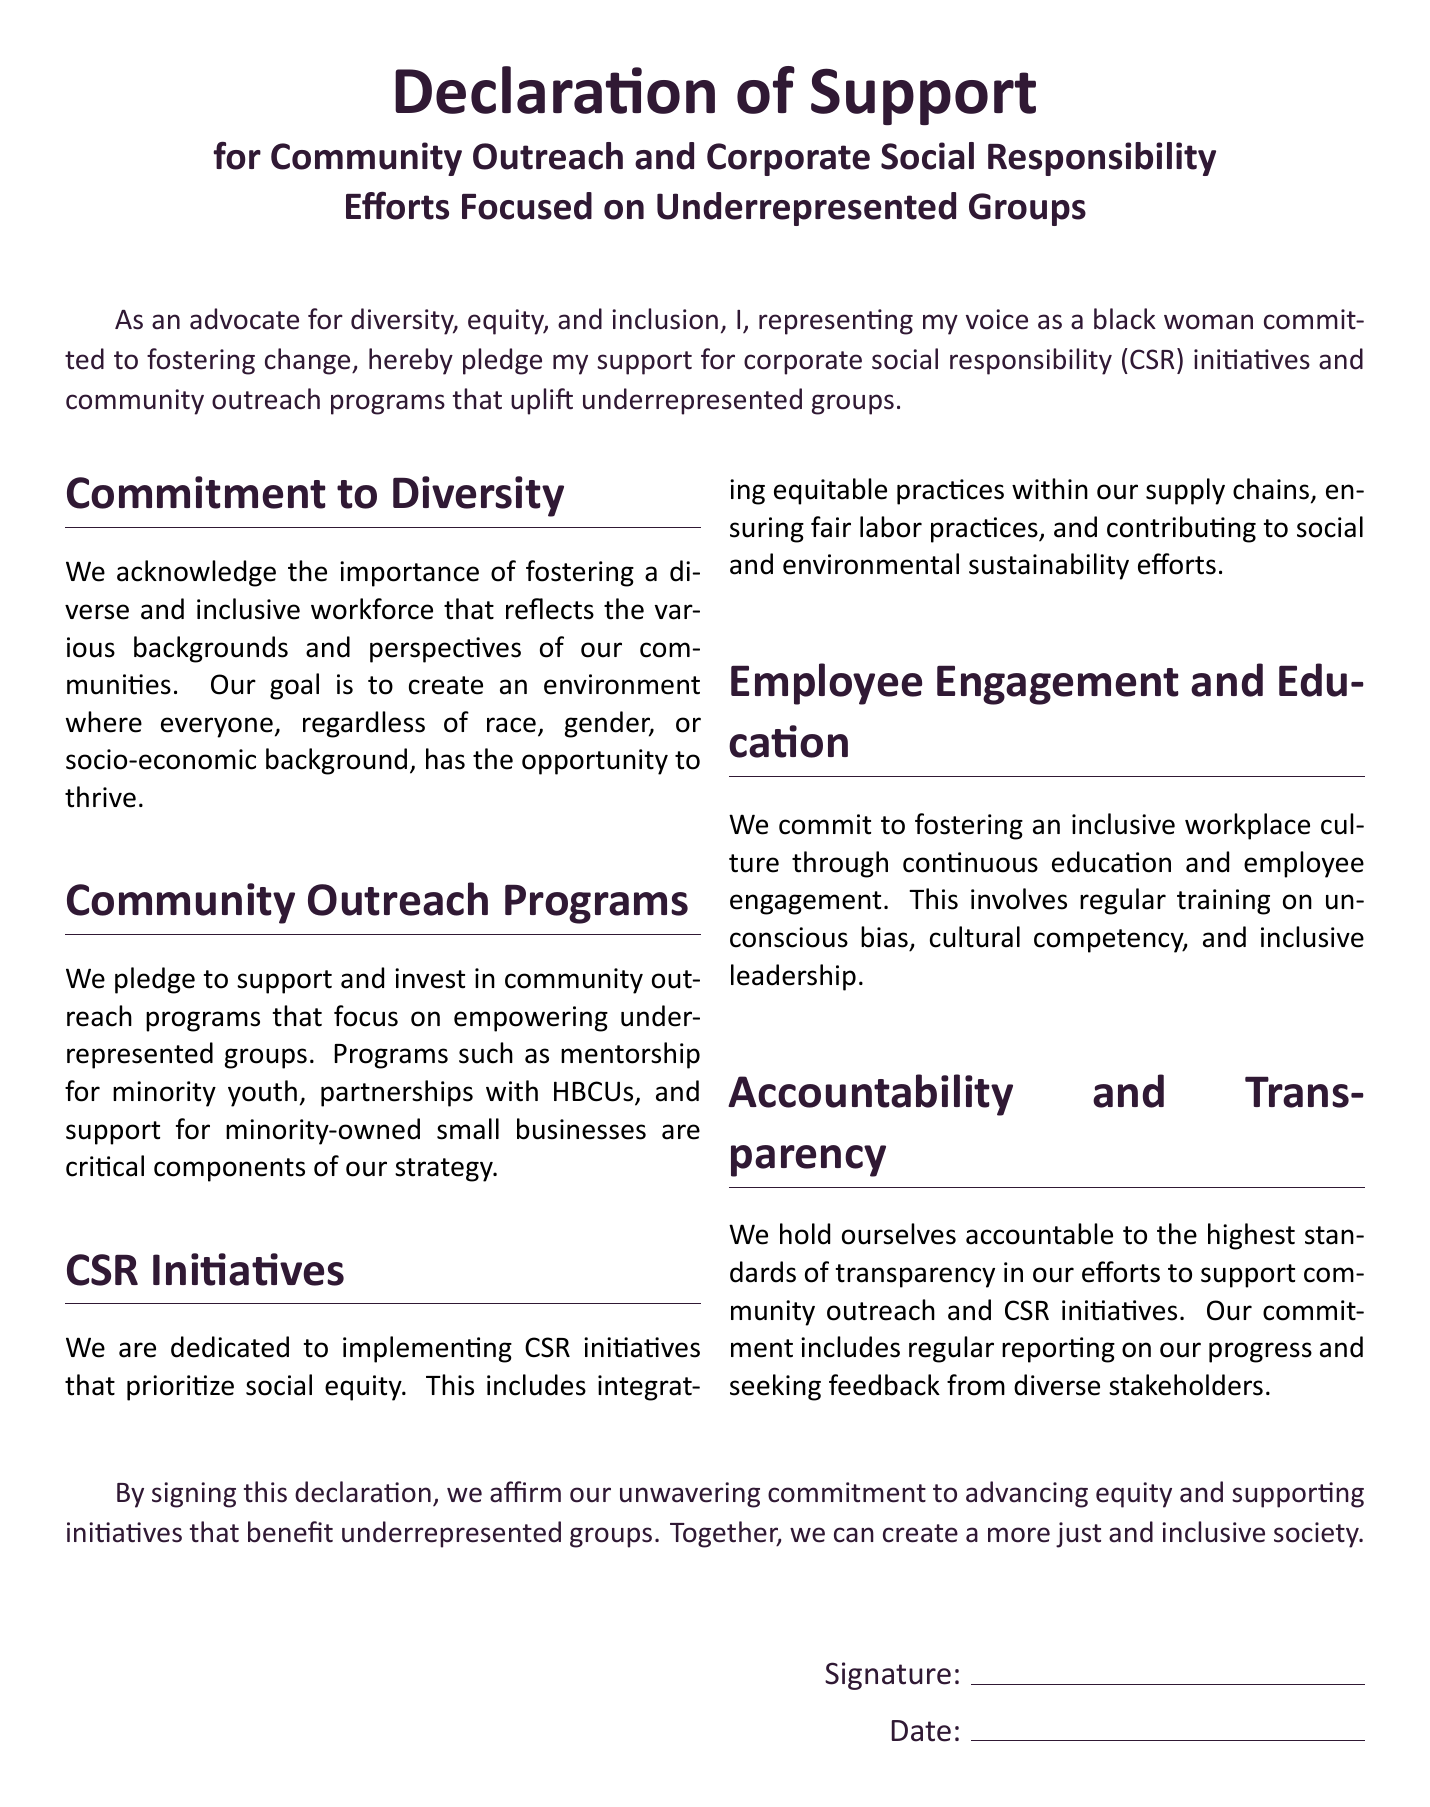What is the title of the document? The title is clearly stated at the beginning of the document.
Answer: Declaration of Support for Community Outreach and Corporate Social Responsibility Efforts Focused on Underrepresented Groups Who is the representative pledging support? The representative is identified in the opening statement of the document.
Answer: a black woman What is one of the goals mentioned in the Commitment to Diversity section? The goal addresses the aspiration for a diverse workforce as stated in the document.
Answer: create an environment where everyone has the opportunity to thrive What type of programs does the document specifically pledge to support? This information is found in the section about community outreach programs.
Answer: community outreach programs that focus on empowering underrepresented groups What is emphasized in the CSR Initiatives section? The section mentions priorities that the organization aims to address through initiatives.
Answer: social equity Which type of training is mentioned under Employee Engagement and Education? The training is part of the commitment to foster an inclusive workplace culture.
Answer: unconscious bias What is mentioned regarding accountability? This statement reflects the promise made by the organization in terms of their standards.
Answer: highest standards of transparency What affirmation is made upon signing the declaration? This concluding statement expresses the commitment of the signatories regarding their goals.
Answer: advancing equity and supporting initiatives that benefit underrepresented groups 